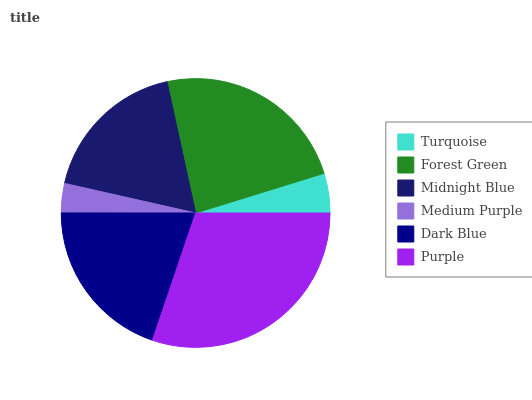Is Medium Purple the minimum?
Answer yes or no. Yes. Is Purple the maximum?
Answer yes or no. Yes. Is Forest Green the minimum?
Answer yes or no. No. Is Forest Green the maximum?
Answer yes or no. No. Is Forest Green greater than Turquoise?
Answer yes or no. Yes. Is Turquoise less than Forest Green?
Answer yes or no. Yes. Is Turquoise greater than Forest Green?
Answer yes or no. No. Is Forest Green less than Turquoise?
Answer yes or no. No. Is Dark Blue the high median?
Answer yes or no. Yes. Is Midnight Blue the low median?
Answer yes or no. Yes. Is Medium Purple the high median?
Answer yes or no. No. Is Medium Purple the low median?
Answer yes or no. No. 